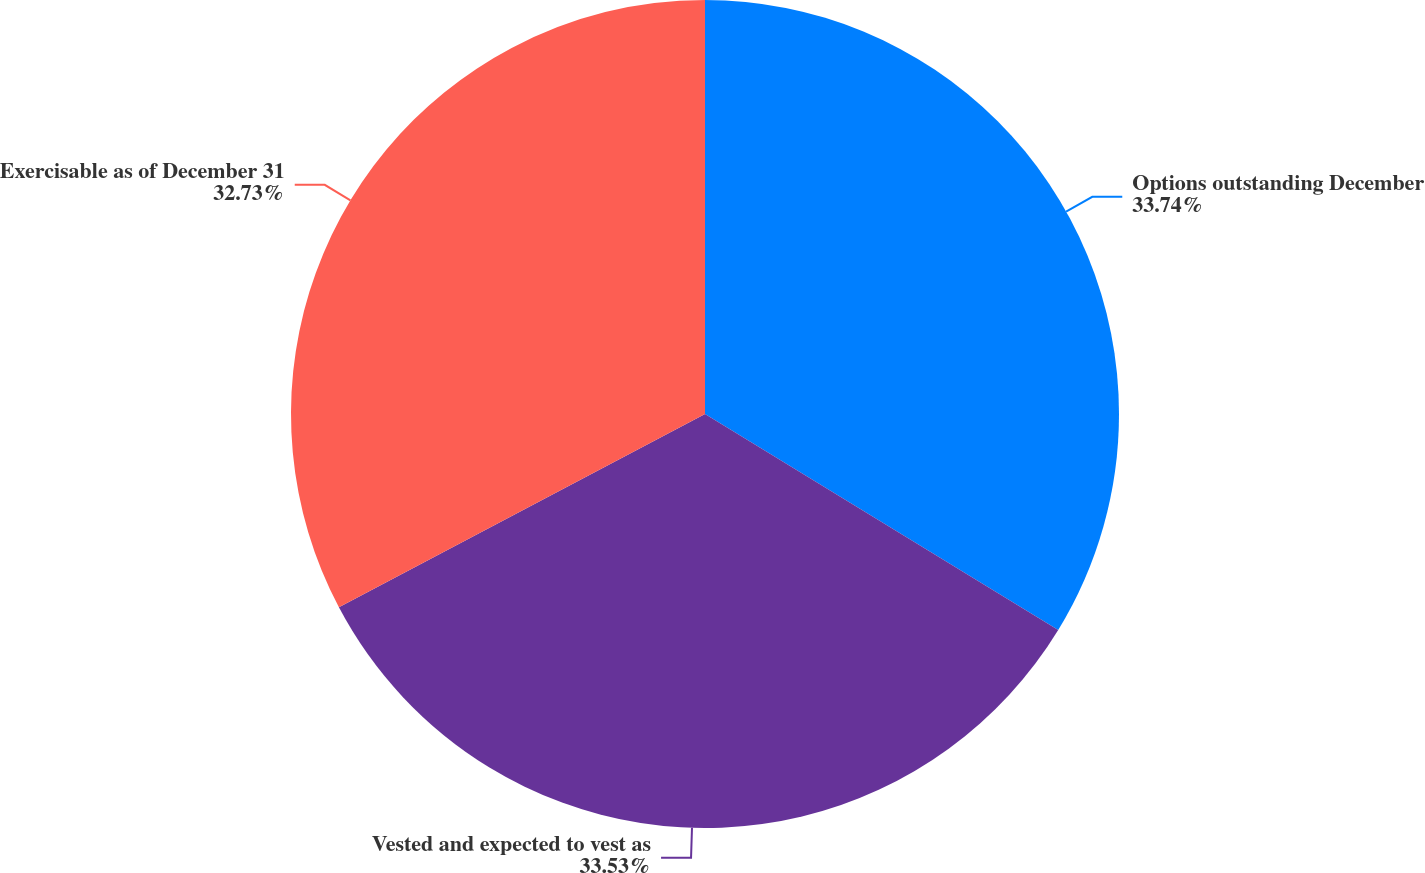Convert chart. <chart><loc_0><loc_0><loc_500><loc_500><pie_chart><fcel>Options outstanding December<fcel>Vested and expected to vest as<fcel>Exercisable as of December 31<nl><fcel>33.73%<fcel>33.53%<fcel>32.73%<nl></chart> 